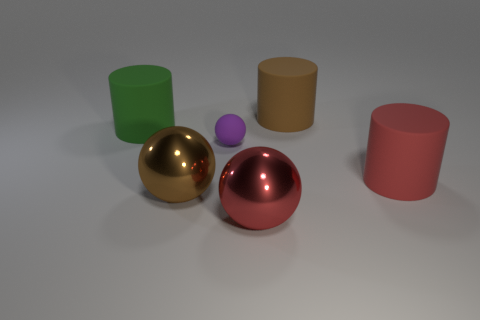Subtract all large spheres. How many spheres are left? 1 Add 1 brown metallic objects. How many objects exist? 7 Add 3 tiny objects. How many tiny objects are left? 4 Add 2 red spheres. How many red spheres exist? 3 Subtract 0 gray blocks. How many objects are left? 6 Subtract all tiny green metallic objects. Subtract all brown metallic spheres. How many objects are left? 5 